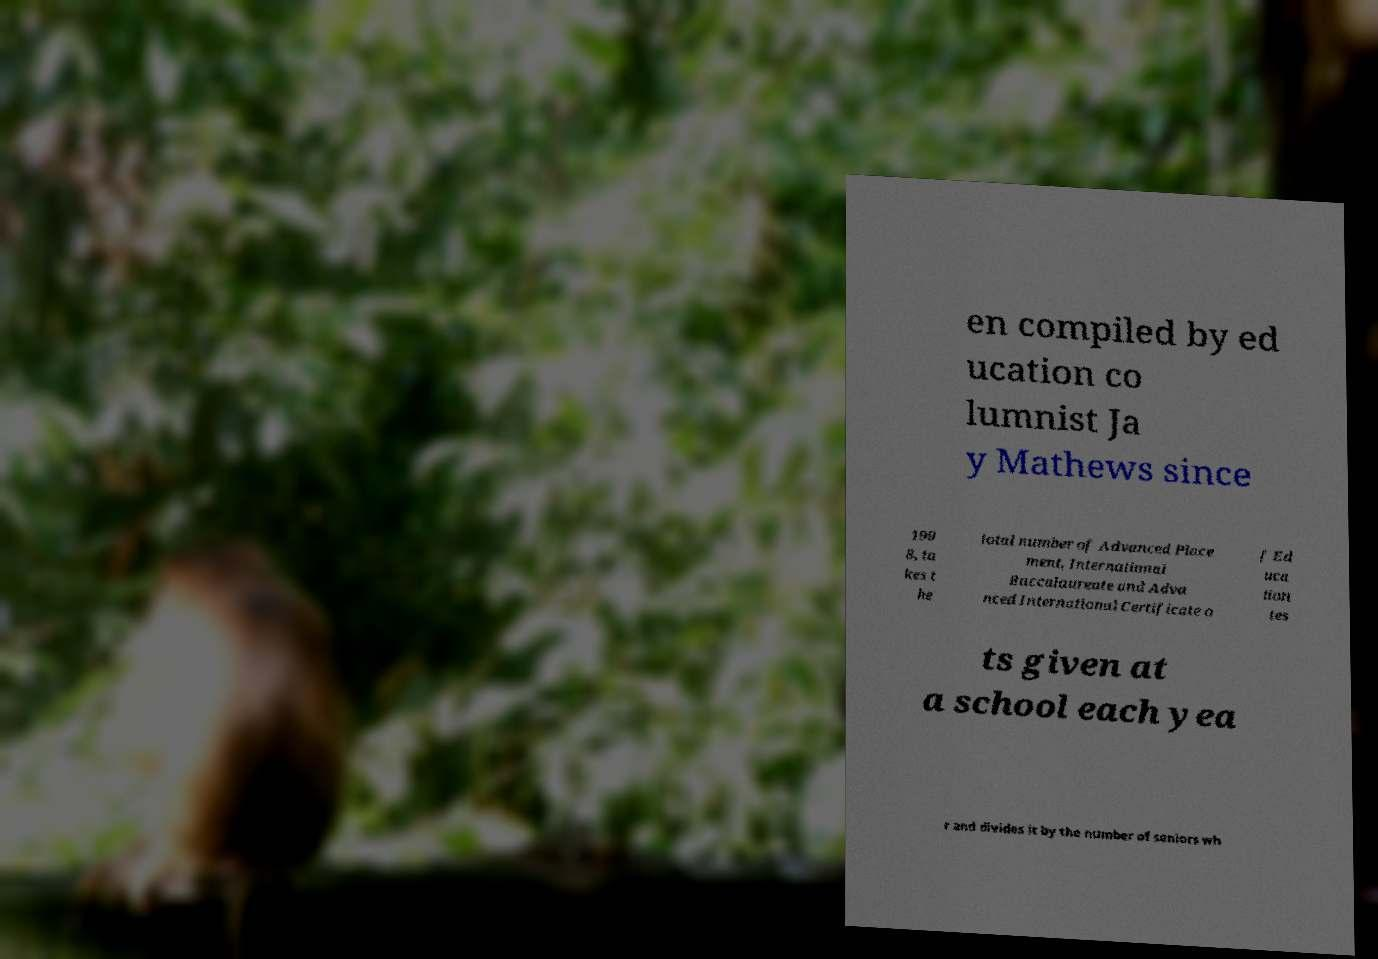What messages or text are displayed in this image? I need them in a readable, typed format. en compiled by ed ucation co lumnist Ja y Mathews since 199 8, ta kes t he total number of Advanced Place ment, International Baccalaureate and Adva nced International Certificate o f Ed uca tion tes ts given at a school each yea r and divides it by the number of seniors wh 